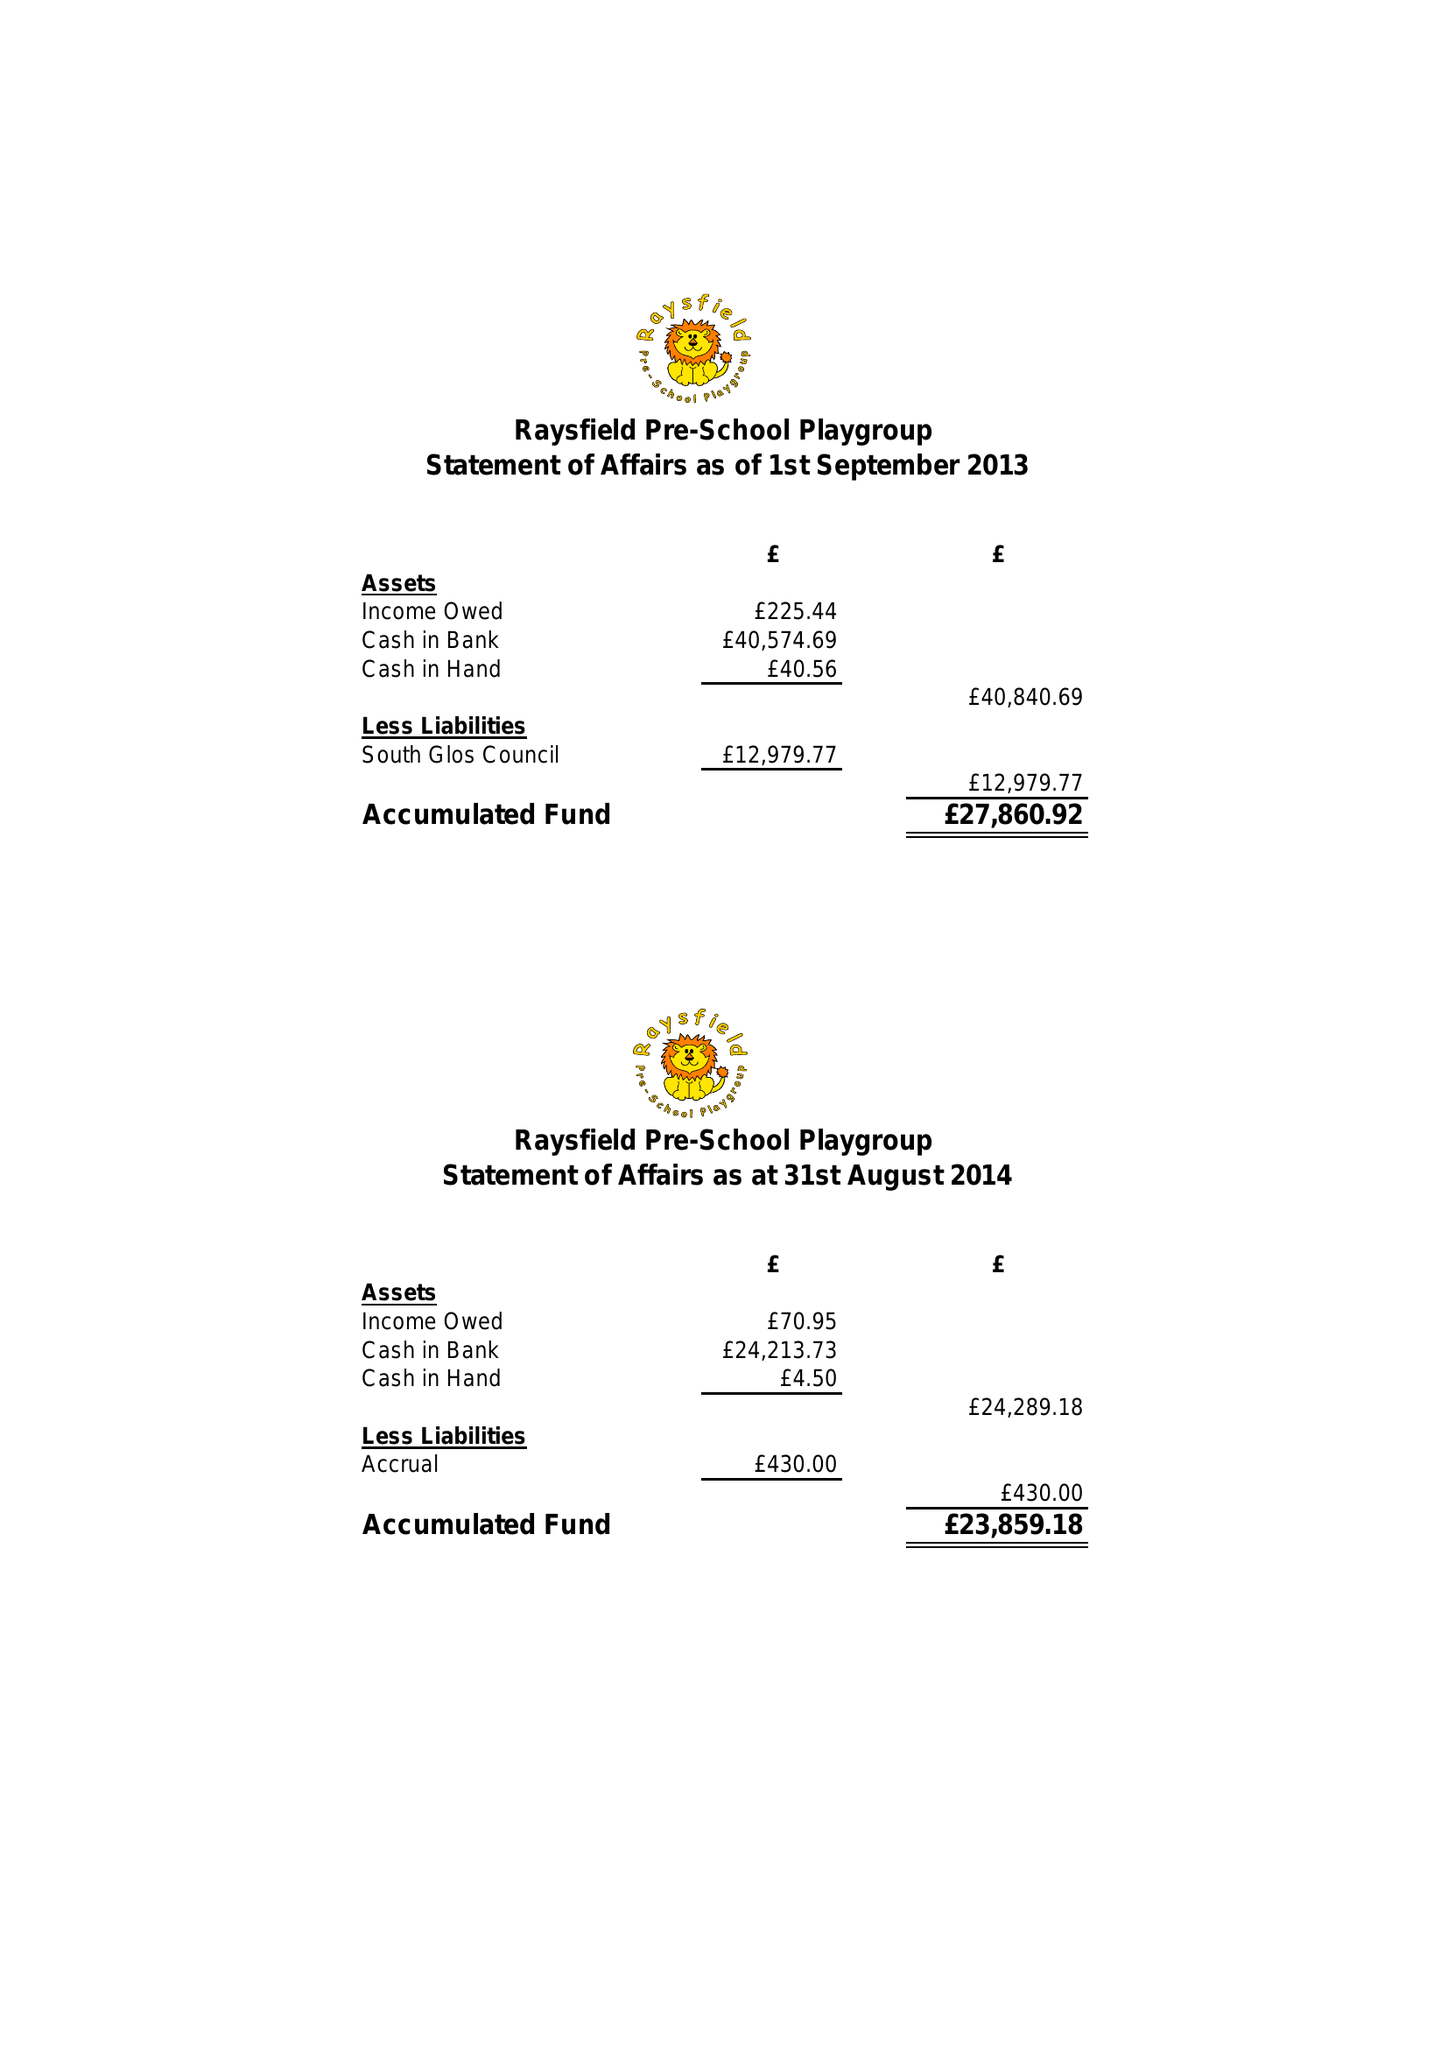What is the value for the address__street_line?
Answer the question using a single word or phrase. FINCH ROAD 